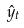Convert formula to latex. <formula><loc_0><loc_0><loc_500><loc_500>\hat { y } _ { t }</formula> 